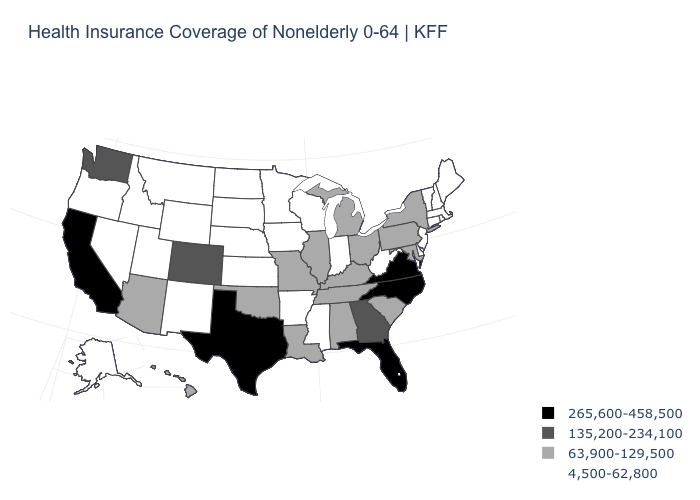Among the states that border Tennessee , which have the lowest value?
Be succinct. Arkansas, Mississippi. What is the value of New Hampshire?
Short answer required. 4,500-62,800. What is the value of Oklahoma?
Write a very short answer. 63,900-129,500. What is the lowest value in states that border Kentucky?
Short answer required. 4,500-62,800. Name the states that have a value in the range 63,900-129,500?
Give a very brief answer. Alabama, Arizona, Hawaii, Illinois, Kentucky, Louisiana, Maryland, Michigan, Missouri, New York, Ohio, Oklahoma, Pennsylvania, South Carolina, Tennessee. Does the first symbol in the legend represent the smallest category?
Give a very brief answer. No. Among the states that border Connecticut , does Rhode Island have the lowest value?
Keep it brief. Yes. What is the highest value in the MidWest ?
Be succinct. 63,900-129,500. Does the map have missing data?
Quick response, please. No. Name the states that have a value in the range 63,900-129,500?
Quick response, please. Alabama, Arizona, Hawaii, Illinois, Kentucky, Louisiana, Maryland, Michigan, Missouri, New York, Ohio, Oklahoma, Pennsylvania, South Carolina, Tennessee. Does Iowa have the same value as Indiana?
Keep it brief. Yes. Does the first symbol in the legend represent the smallest category?
Give a very brief answer. No. What is the value of Michigan?
Answer briefly. 63,900-129,500. What is the value of Louisiana?
Keep it brief. 63,900-129,500. Does North Carolina have the highest value in the South?
Keep it brief. Yes. 